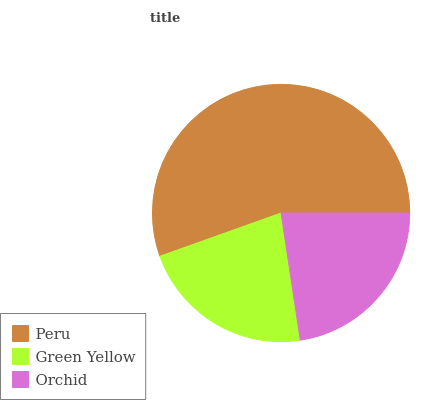Is Green Yellow the minimum?
Answer yes or no. Yes. Is Peru the maximum?
Answer yes or no. Yes. Is Orchid the minimum?
Answer yes or no. No. Is Orchid the maximum?
Answer yes or no. No. Is Orchid greater than Green Yellow?
Answer yes or no. Yes. Is Green Yellow less than Orchid?
Answer yes or no. Yes. Is Green Yellow greater than Orchid?
Answer yes or no. No. Is Orchid less than Green Yellow?
Answer yes or no. No. Is Orchid the high median?
Answer yes or no. Yes. Is Orchid the low median?
Answer yes or no. Yes. Is Peru the high median?
Answer yes or no. No. Is Peru the low median?
Answer yes or no. No. 